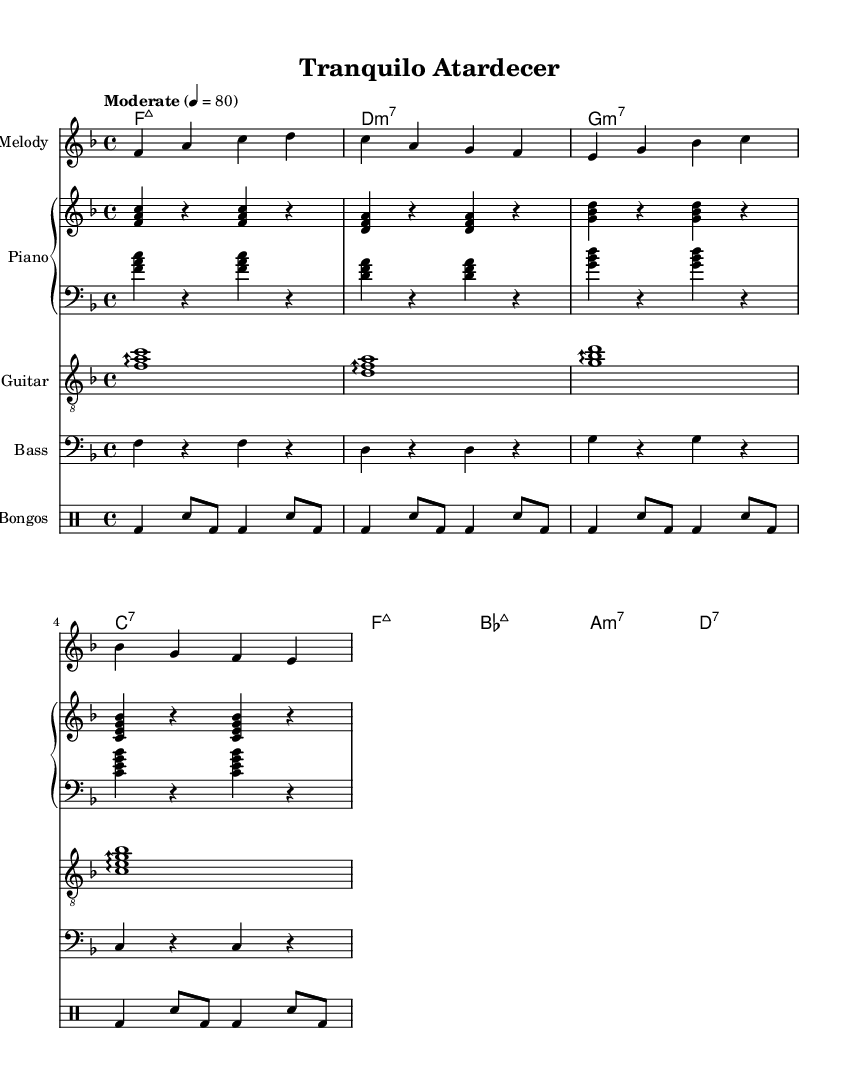What is the key signature of this music? The key signature is F major, which has one flat (B flat). You can find this indicated at the beginning of the staff.
Answer: F major What is the time signature of this music? The time signature is 4/4, shown at the beginning of the piece. It indicates four beats per measure, with the quarter note receiving one beat.
Answer: 4/4 What is the tempo marking of this piece? The tempo marking is "Moderate," with a quarter note tempo of 80. It's shown at the beginning of the score and indicates the speed of the piece.
Answer: Moderate How many measures are there in the melody? There are eight measures in the melody. You can count each grouping of bars with vertical lines, which indicate the end of a measure.
Answer: Eight What chord follows F major 7 in the chord progression? The chord that follows F major 7 is D minor 7. You can identify this by looking at the chord progression listed beneath the melody.
Answer: D minor 7 What is the instrumentation used in this piece? The instrumentation includes melody, piano, guitar, bass, and bongos. You can see the different staff names at the beginning of each section, indicating the instruments.
Answer: Melody, piano, guitar, bass, bongos Which rhythm instrument is used in this score? The rhythm instrument used in this score is bongos. The notation indicates a drum staff specifically for the bongos, showing its role in the piece.
Answer: Bongos 